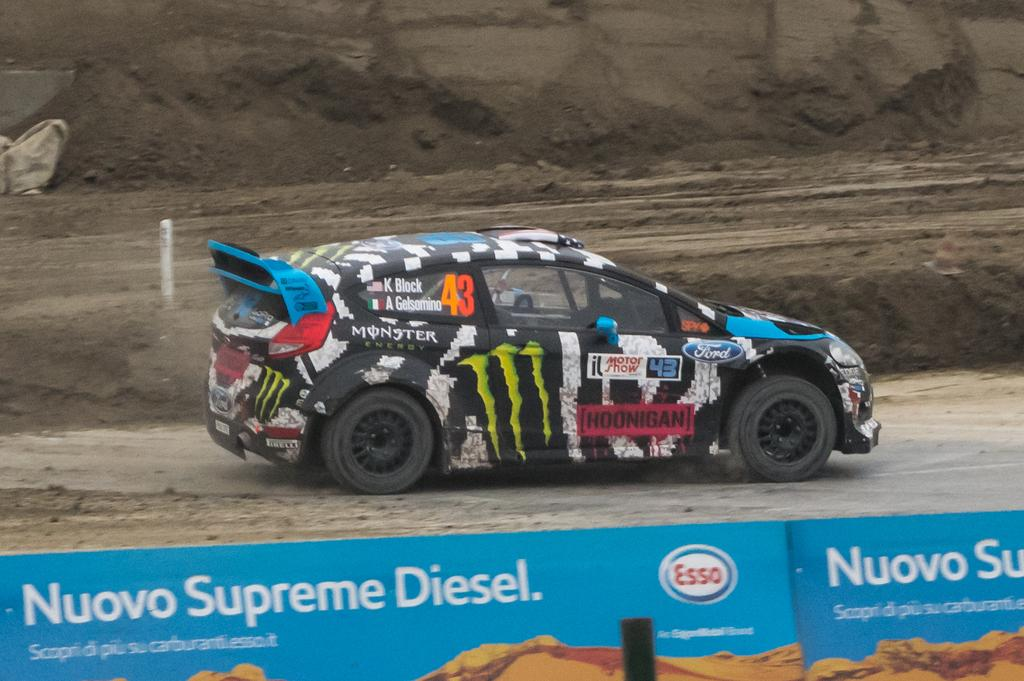What is on the road in the image? There is a vehicle on the road in the image. What can be seen in the background of the image? There are rocks and a pole in the background of the image. What is written at the bottom of the image? There is some text at the bottom of the image. What is on the board in the image? There is a logo on the board. How many people have died in the image? There is no indication of death or any people in the image, so it cannot be determined. 